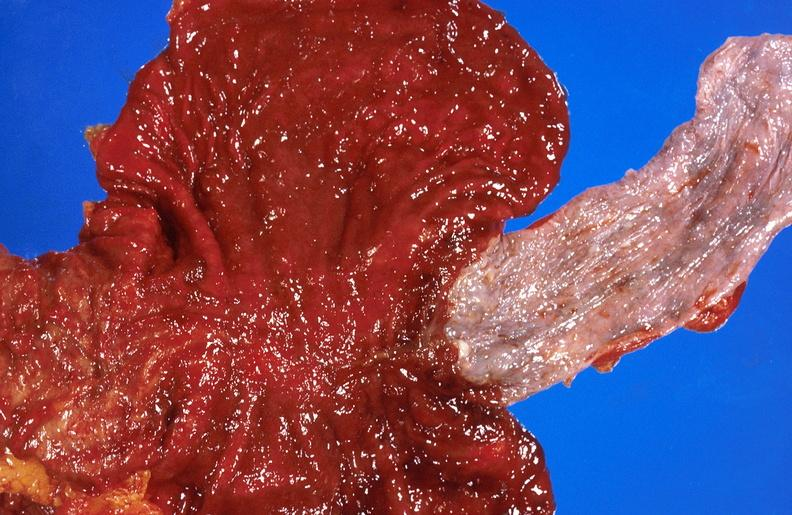s palmar crease normal present?
Answer the question using a single word or phrase. No 